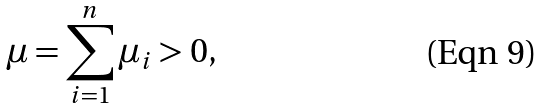<formula> <loc_0><loc_0><loc_500><loc_500>\mu = \sum _ { i = 1 } ^ { n } \mu _ { i } > 0 ,</formula> 